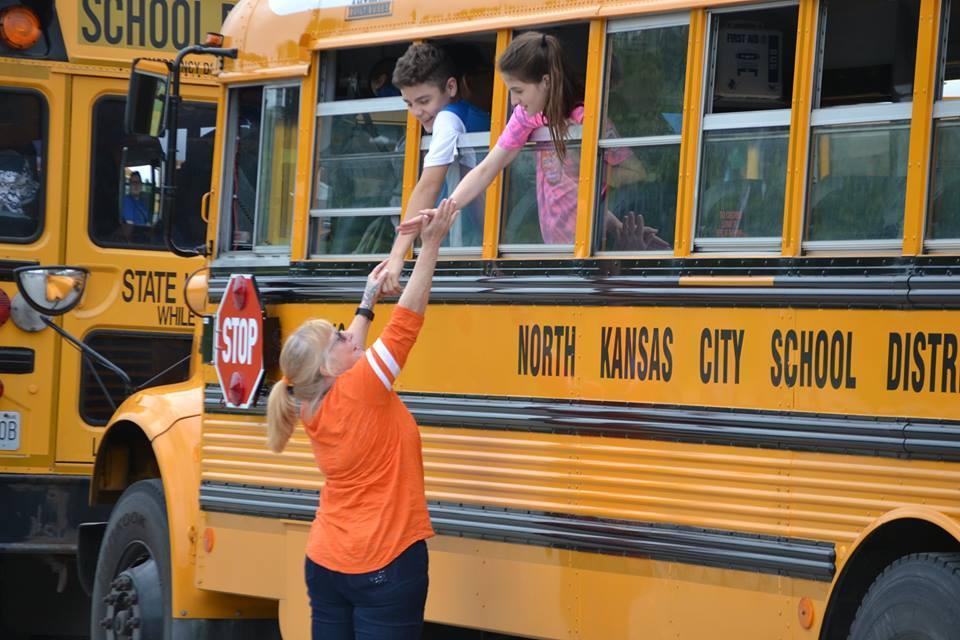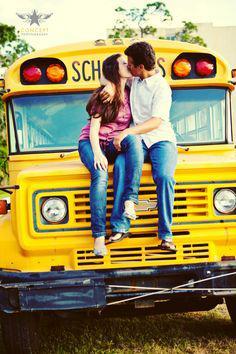The first image is the image on the left, the second image is the image on the right. Evaluate the accuracy of this statement regarding the images: "In one of the images, there is a person standing outside of the bus.". Is it true? Answer yes or no. Yes. 